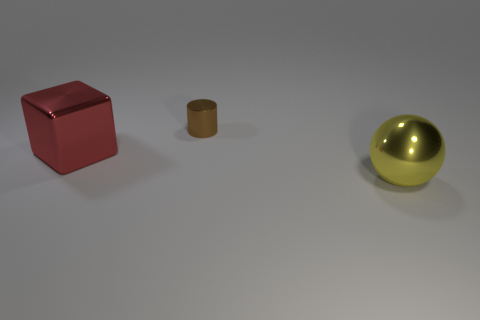There is a object that is the same size as the block; what is its material?
Offer a terse response. Metal. What size is the object that is in front of the big red thing?
Keep it short and to the point. Large. There is a thing in front of the big red thing; does it have the same size as the thing that is to the left of the brown metal thing?
Offer a terse response. Yes. How many small purple cylinders are the same material as the large yellow thing?
Provide a short and direct response. 0. What color is the tiny thing?
Your answer should be very brief. Brown. Are there any large metallic spheres in front of the block?
Provide a short and direct response. Yes. What is the size of the metallic thing behind the object to the left of the small brown metallic object?
Provide a short and direct response. Small. There is a large red metal thing; what shape is it?
Offer a very short reply. Cube. There is a thing that is in front of the big shiny thing to the left of the metallic thing that is in front of the red shiny cube; what color is it?
Provide a succinct answer. Yellow. The sphere that is the same size as the red cube is what color?
Keep it short and to the point. Yellow. 